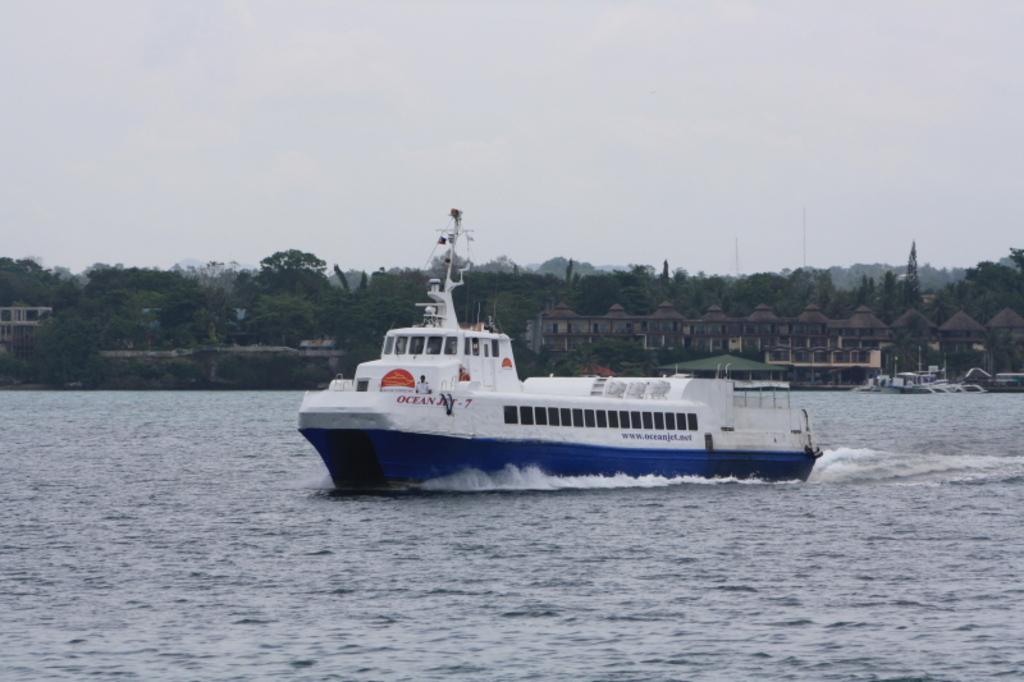In one or two sentences, can you explain what this image depicts? In the image we can see a boat in the water. Here we can see buildings and trees. Here we can see the poles and the sky. 